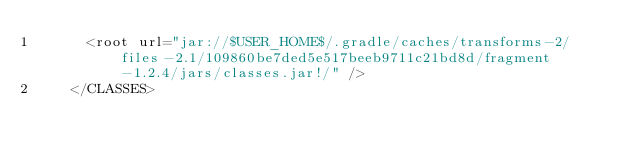<code> <loc_0><loc_0><loc_500><loc_500><_XML_>      <root url="jar://$USER_HOME$/.gradle/caches/transforms-2/files-2.1/109860be7ded5e517beeb9711c21bd8d/fragment-1.2.4/jars/classes.jar!/" />
    </CLASSES></code> 